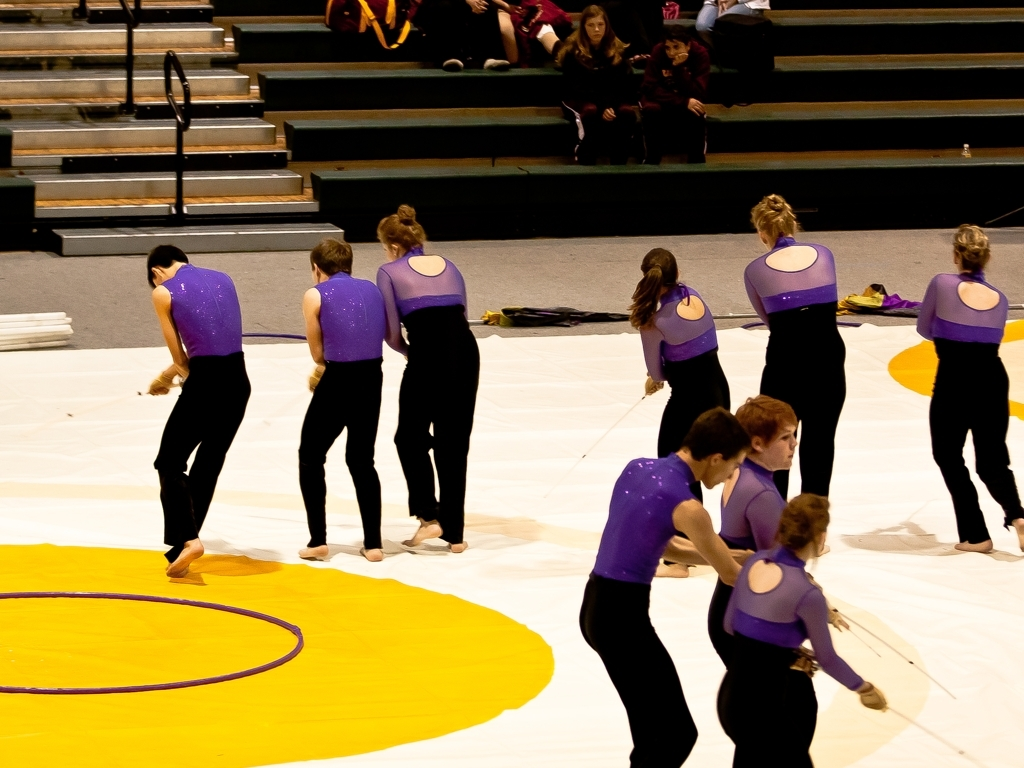Can you describe the activity taking place in this image? The image captures a group of performers dressed in matching purple and black attire during a routine, possibly at a dance or gymnastics event. They appear to be focused and synchronized, indicating a rehearsed performance. What details can you infer about the setting of this performance? The event is seemingly indoors, as suggested by the artificial lighting and the presence of tiered seating, where an audience can be observed in the background. The large yellow pattern on the floor hints at a special mat or canvas, which is often used in dance competitions or gymnastics. 